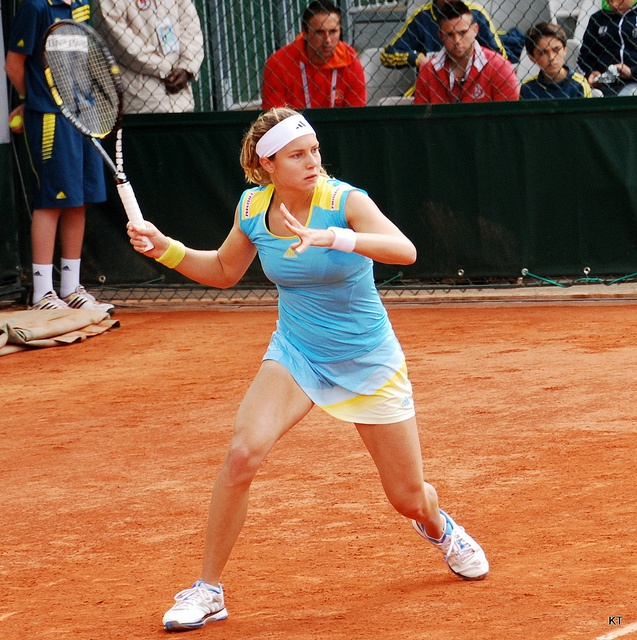Describe the objects in this image and their specific colors. I can see people in black, white, tan, lightblue, and red tones, people in black, navy, maroon, and brown tones, people in black, lightgray, and darkgray tones, tennis racket in black, gray, darkgray, and lightgray tones, and people in black, maroon, red, and brown tones in this image. 